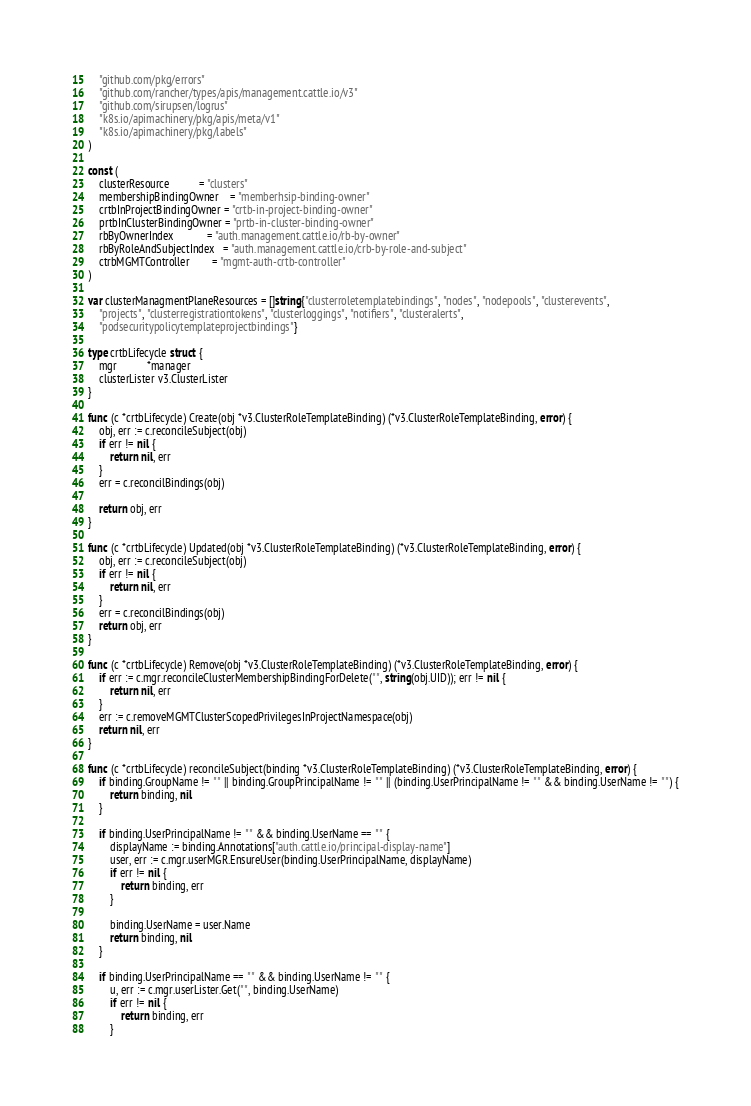<code> <loc_0><loc_0><loc_500><loc_500><_Go_>	"github.com/pkg/errors"
	"github.com/rancher/types/apis/management.cattle.io/v3"
	"github.com/sirupsen/logrus"
	"k8s.io/apimachinery/pkg/apis/meta/v1"
	"k8s.io/apimachinery/pkg/labels"
)

const (
	clusterResource           = "clusters"
	membershipBindingOwner    = "memberhsip-binding-owner"
	crtbInProjectBindingOwner = "crtb-in-project-binding-owner"
	prtbInClusterBindingOwner = "prtb-in-cluster-binding-owner"
	rbByOwnerIndex            = "auth.management.cattle.io/rb-by-owner"
	rbByRoleAndSubjectIndex   = "auth.management.cattle.io/crb-by-role-and-subject"
	ctrbMGMTController        = "mgmt-auth-crtb-controller"
)

var clusterManagmentPlaneResources = []string{"clusterroletemplatebindings", "nodes", "nodepools", "clusterevents",
	"projects", "clusterregistrationtokens", "clusterloggings", "notifiers", "clusteralerts",
	"podsecuritypolicytemplateprojectbindings"}

type crtbLifecycle struct {
	mgr           *manager
	clusterLister v3.ClusterLister
}

func (c *crtbLifecycle) Create(obj *v3.ClusterRoleTemplateBinding) (*v3.ClusterRoleTemplateBinding, error) {
	obj, err := c.reconcileSubject(obj)
	if err != nil {
		return nil, err
	}
	err = c.reconcilBindings(obj)

	return obj, err
}

func (c *crtbLifecycle) Updated(obj *v3.ClusterRoleTemplateBinding) (*v3.ClusterRoleTemplateBinding, error) {
	obj, err := c.reconcileSubject(obj)
	if err != nil {
		return nil, err
	}
	err = c.reconcilBindings(obj)
	return obj, err
}

func (c *crtbLifecycle) Remove(obj *v3.ClusterRoleTemplateBinding) (*v3.ClusterRoleTemplateBinding, error) {
	if err := c.mgr.reconcileClusterMembershipBindingForDelete("", string(obj.UID)); err != nil {
		return nil, err
	}
	err := c.removeMGMTClusterScopedPrivilegesInProjectNamespace(obj)
	return nil, err
}

func (c *crtbLifecycle) reconcileSubject(binding *v3.ClusterRoleTemplateBinding) (*v3.ClusterRoleTemplateBinding, error) {
	if binding.GroupName != "" || binding.GroupPrincipalName != "" || (binding.UserPrincipalName != "" && binding.UserName != "") {
		return binding, nil
	}

	if binding.UserPrincipalName != "" && binding.UserName == "" {
		displayName := binding.Annotations["auth.cattle.io/principal-display-name"]
		user, err := c.mgr.userMGR.EnsureUser(binding.UserPrincipalName, displayName)
		if err != nil {
			return binding, err
		}

		binding.UserName = user.Name
		return binding, nil
	}

	if binding.UserPrincipalName == "" && binding.UserName != "" {
		u, err := c.mgr.userLister.Get("", binding.UserName)
		if err != nil {
			return binding, err
		}</code> 